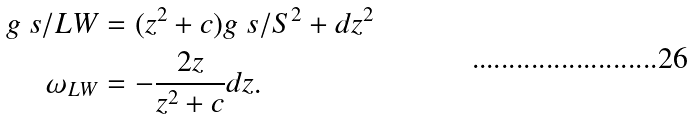Convert formula to latex. <formula><loc_0><loc_0><loc_500><loc_500>g \ s / { L W } & = ( z ^ { 2 } + c ) g \ s / { S ^ { 2 } } + d z ^ { 2 } \\ \omega _ { L W } & = - \frac { 2 z } { z ^ { 2 } + c } d z .</formula> 